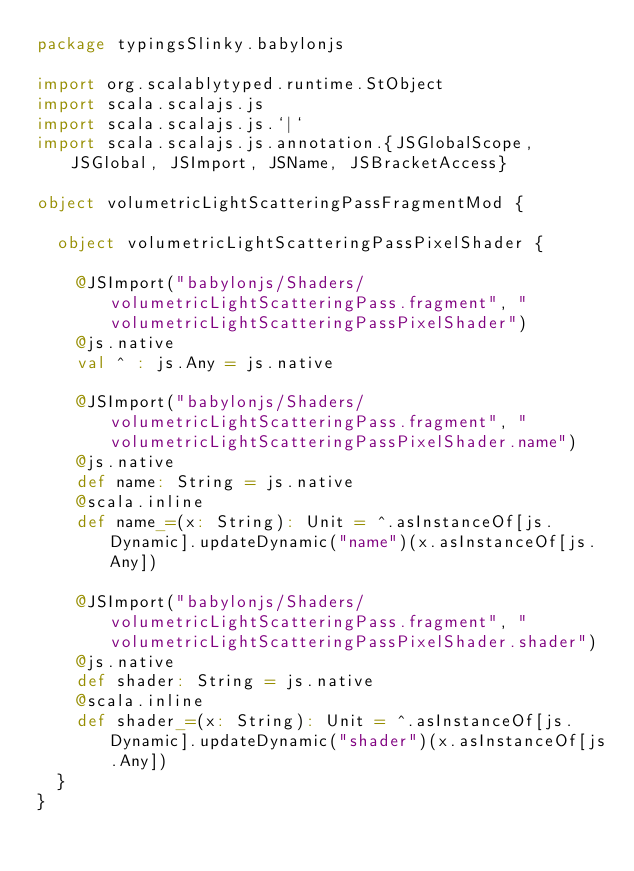<code> <loc_0><loc_0><loc_500><loc_500><_Scala_>package typingsSlinky.babylonjs

import org.scalablytyped.runtime.StObject
import scala.scalajs.js
import scala.scalajs.js.`|`
import scala.scalajs.js.annotation.{JSGlobalScope, JSGlobal, JSImport, JSName, JSBracketAccess}

object volumetricLightScatteringPassFragmentMod {
  
  object volumetricLightScatteringPassPixelShader {
    
    @JSImport("babylonjs/Shaders/volumetricLightScatteringPass.fragment", "volumetricLightScatteringPassPixelShader")
    @js.native
    val ^ : js.Any = js.native
    
    @JSImport("babylonjs/Shaders/volumetricLightScatteringPass.fragment", "volumetricLightScatteringPassPixelShader.name")
    @js.native
    def name: String = js.native
    @scala.inline
    def name_=(x: String): Unit = ^.asInstanceOf[js.Dynamic].updateDynamic("name")(x.asInstanceOf[js.Any])
    
    @JSImport("babylonjs/Shaders/volumetricLightScatteringPass.fragment", "volumetricLightScatteringPassPixelShader.shader")
    @js.native
    def shader: String = js.native
    @scala.inline
    def shader_=(x: String): Unit = ^.asInstanceOf[js.Dynamic].updateDynamic("shader")(x.asInstanceOf[js.Any])
  }
}
</code> 